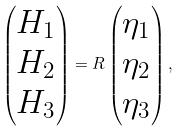<formula> <loc_0><loc_0><loc_500><loc_500>\begin{pmatrix} H _ { 1 } \\ H _ { 2 } \\ H _ { 3 } \end{pmatrix} = R \begin{pmatrix} \eta _ { 1 } \\ \eta _ { 2 } \\ \eta _ { 3 } \end{pmatrix} ,</formula> 